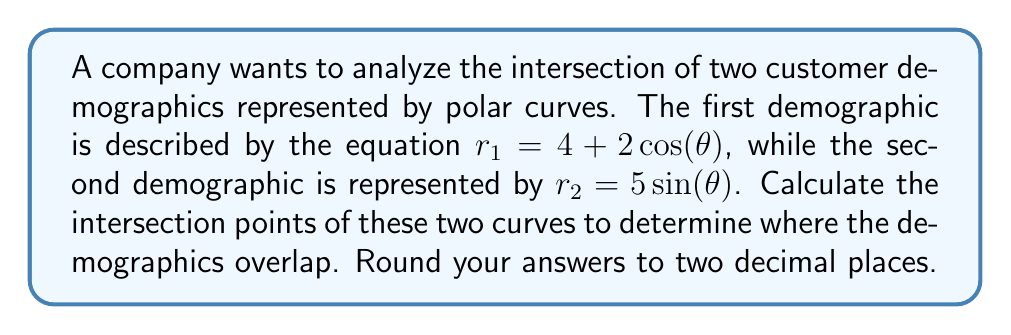Solve this math problem. To find the intersection points of the two polar curves, we need to set the equations equal to each other and solve for $\theta$:

$$4 + 2\cos(\theta) = 5\sin(\theta)$$

Rearranging the equation:

$$2\cos(\theta) - 5\sin(\theta) = -4$$

We can use the substitution method to solve this equation. Let $\tan(\frac{\theta}{2}) = t$. Then:

$$\cos(\theta) = \frac{1-t^2}{1+t^2}$$
$$\sin(\theta) = \frac{2t}{1+t^2}$$

Substituting these into our equation:

$$2\left(\frac{1-t^2}{1+t^2}\right) - 5\left(\frac{2t}{1+t^2}\right) = -4$$

Multiplying both sides by $(1+t^2)$:

$$2(1-t^2) - 10t = -4(1+t^2)$$

Expanding:

$$2 - 2t^2 - 10t = -4 - 4t^2$$

Rearranging:

$$2t^2 - 10t + 6 = 0$$

This is a quadratic equation. We can solve it using the quadratic formula:

$$t = \frac{10 \pm \sqrt{100 - 48}}{4} = \frac{10 \pm \sqrt{52}}{4}$$

$$t_1 = \frac{10 + \sqrt{52}}{4} \approx 4.30$$
$$t_2 = \frac{10 - \sqrt{52}}{4} \approx 0.70$$

Now we need to convert these back to $\theta$ values:

$$\theta = 2\arctan(t)$$

$$\theta_1 = 2\arctan(4.30) \approx 2.86 \text{ radians} \approx 163.89°$$
$$\theta_2 = 2\arctan(0.70) \approx 1.11 \text{ radians} \approx 63.58°$$

To find the $r$ values, we can substitute these $\theta$ values into either of the original equations. Let's use $r_1 = 4 + 2\cos(\theta)$:

$$r_1 = 4 + 2\cos(2.86) \approx 2.31$$
$$r_2 = 4 + 2\cos(1.11) \approx 5.12$$

Therefore, the intersection points in polar coordinates are approximately $(2.31, 2.86)$ and $(5.12, 1.11)$ in $(r, \theta)$ form.

To convert to Cartesian coordinates:

$$x = r\cos(\theta)$$
$$y = r\sin(\theta)$$

For the first point:
$x_1 = 2.31\cos(2.86) \approx -2.21$
$y_1 = 2.31\sin(2.86) \approx 0.67$

For the second point:
$x_2 = 5.12\cos(1.11) \approx 2.33$
$y_2 = 5.12\sin(1.11) \approx 4.55$
Answer: The two polar curves intersect at approximately $(-2.21, 0.67)$ and $(2.33, 4.55)$ in Cartesian coordinates. 